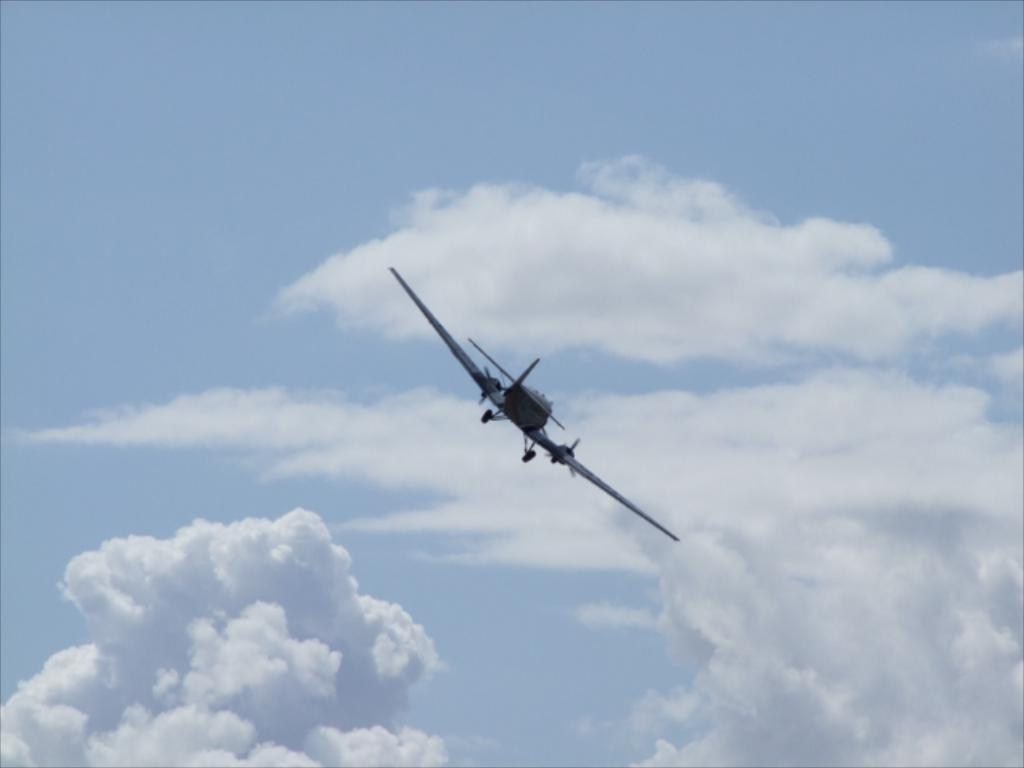How would you summarize this image in a sentence or two? In the image we can see a flying jet in the air and a cloudy sky. 